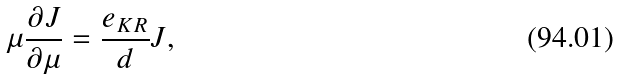Convert formula to latex. <formula><loc_0><loc_0><loc_500><loc_500>\mu \frac { \partial J } { \partial \mu } = \frac { e _ { K R } } { d } J ,</formula> 